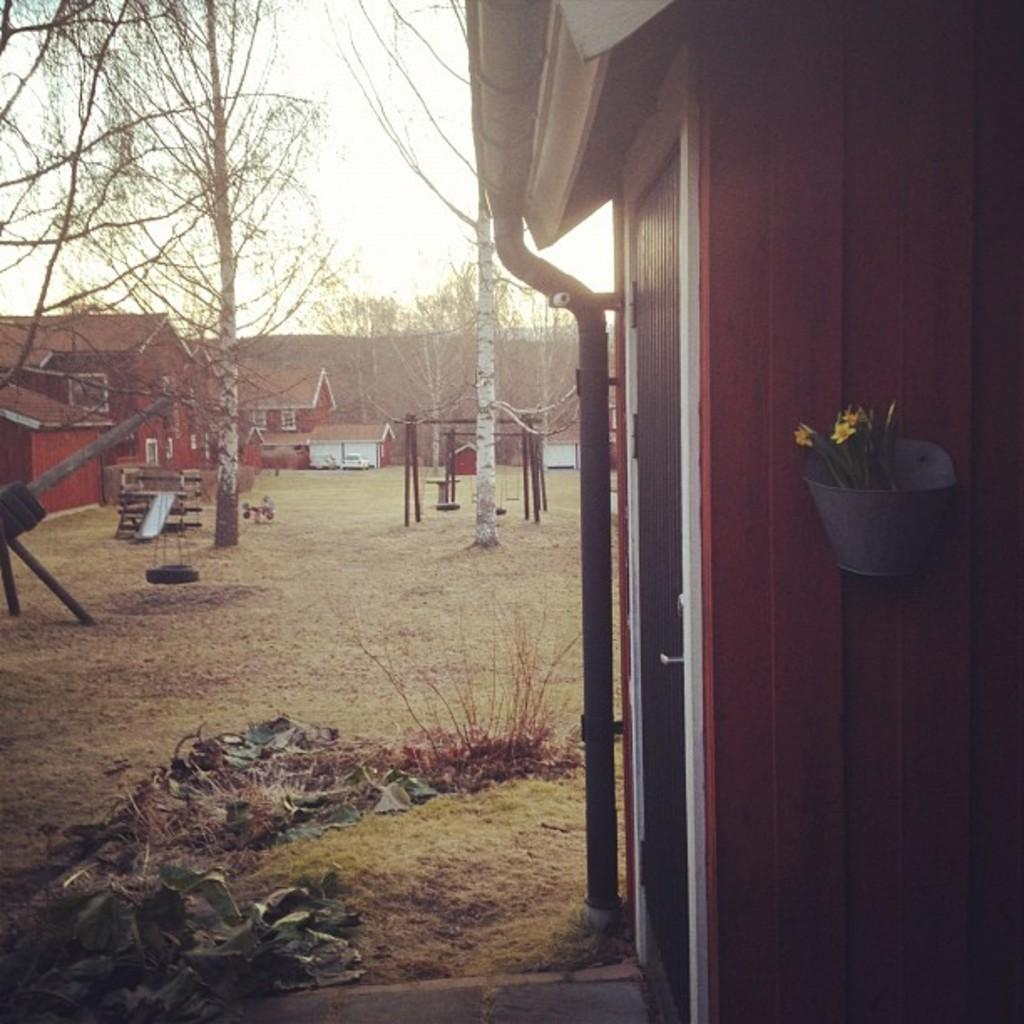What type of structures can be seen in the image? There are houses in the image. What type of vegetation is present in the image? There is a plant, grass, and trees in the image. What unique feature can be seen in the image? There is a skyslide in the image. What else is visible in the image besides the houses, vegetation, and skyslide? There are objects in the image. Where is the zipper located in the image? There is no zipper present in the image. What date is shown on the calendar in the image? There is no calendar present in the image. 